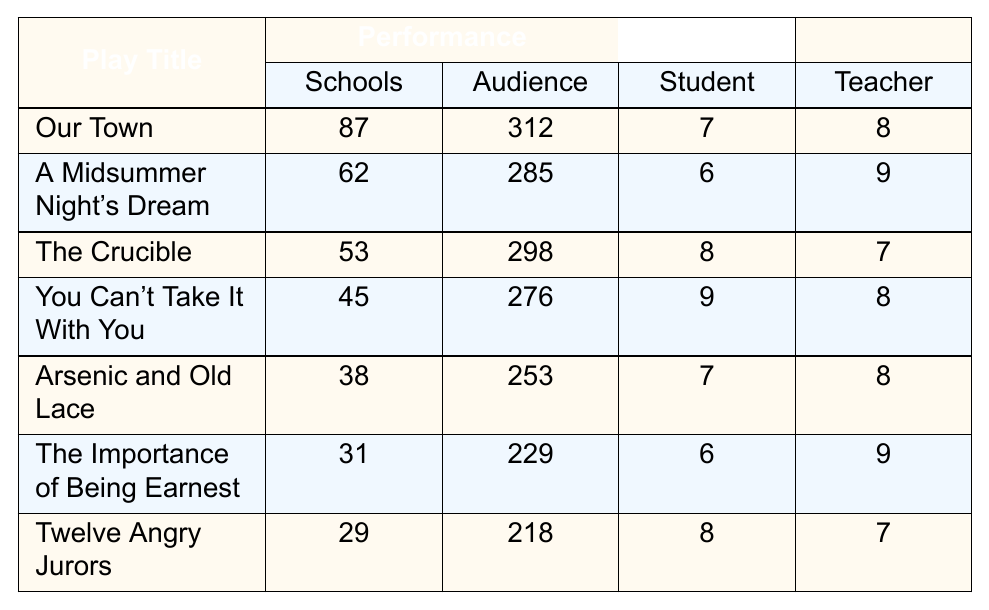What is the play with the highest number of schools performing? According to the table, "Our Town" has the highest number of schools performing, with a total of 87 schools.
Answer: Our Town What is the average audience size for "The Crucible"? The table indicates that the average audience size for "The Crucible" is 298.
Answer: 298 Which play received the highest student enthusiasm level? "You Can't Take It With You" has the highest student enthusiasm level, rated at 9.
Answer: 9 What is the teacher satisfaction rating for "The Importance of Being Earnest"? The table shows that "The Importance of Being Earnest" has a teacher satisfaction rating of 9.
Answer: 9 How many more schools performed "Our Town" than "A Midsummer Night's Dream"? "Our Town" had 87 schools performing, while "A Midsummer Night's Dream" had 62. The difference is 87 - 62 = 25 schools.
Answer: 25 What is the average student enthusiasm level for plays performed? The student enthusiasm levels are 7, 6, 8, 9, 7, 6, and 8. The sum is 51, and there are 7 data points. Thus, the average is 51/7 ≈ 7.29.
Answer: 7.29 Did more schools perform "Arsenic and Old Lace" than "Twelve Angry Jurors"? The table indicates that 38 schools performed "Arsenic and Old Lace," whereas 29 schools performed "Twelve Angry Jurors." Thus, more schools performed "Arsenic and Old Lace."
Answer: Yes Which play had the lowest average audience size? "Twelve Angry Jurors" had the lowest average audience size at 218, based on the table.
Answer: 218 If we consider student enthusiasm levels, which play has a higher average, "The Crucible" or "Arsenic and Old Lace"? "The Crucible" has a student enthusiasm level of 8, while "Arsenic and Old Lace" has a level of 7. Therefore, "The Crucible" has a higher average.
Answer: The Crucible What is the total number of schools performing for all plays listed? To find the total, sum up the number of schools performing: 87 + 62 + 53 + 45 + 38 + 31 + 29 = 345.
Answer: 345 